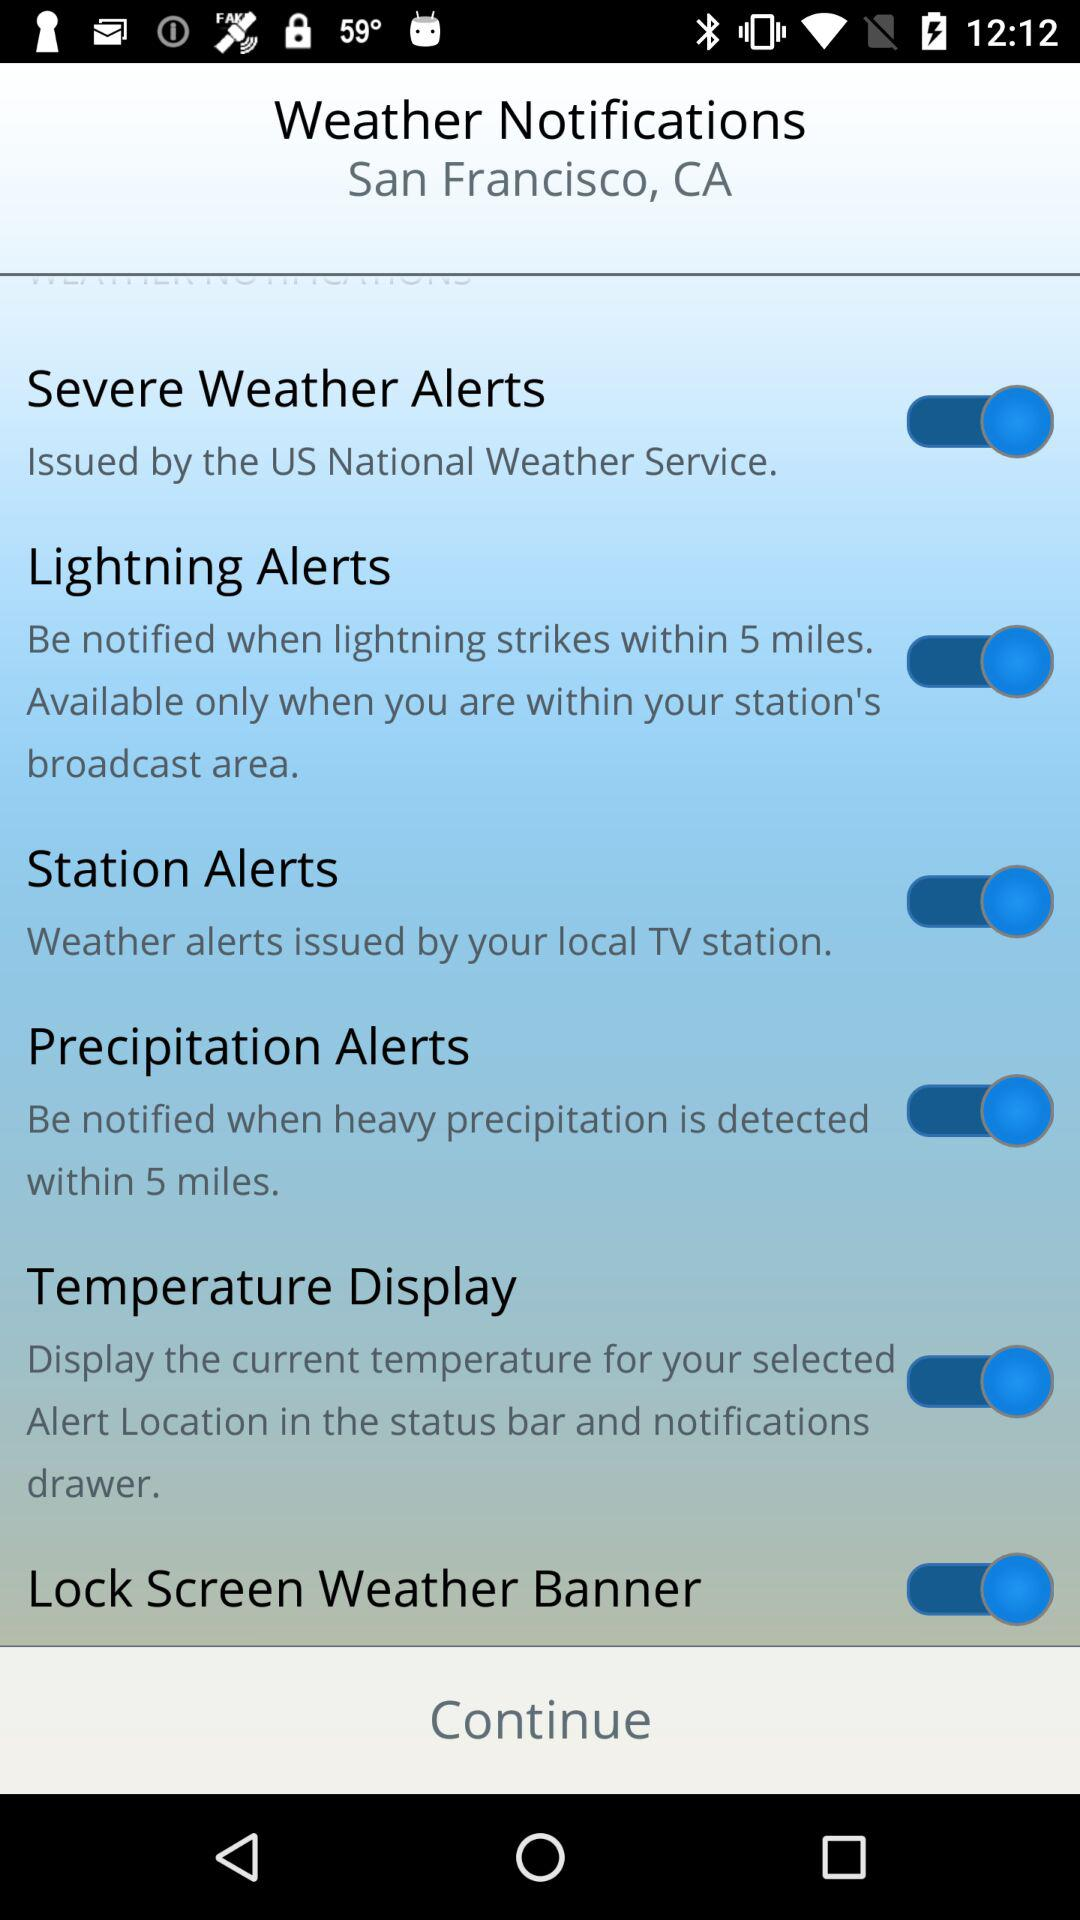How many alerts are available only when you are within your station's broadcast area?
Answer the question using a single word or phrase. 2 